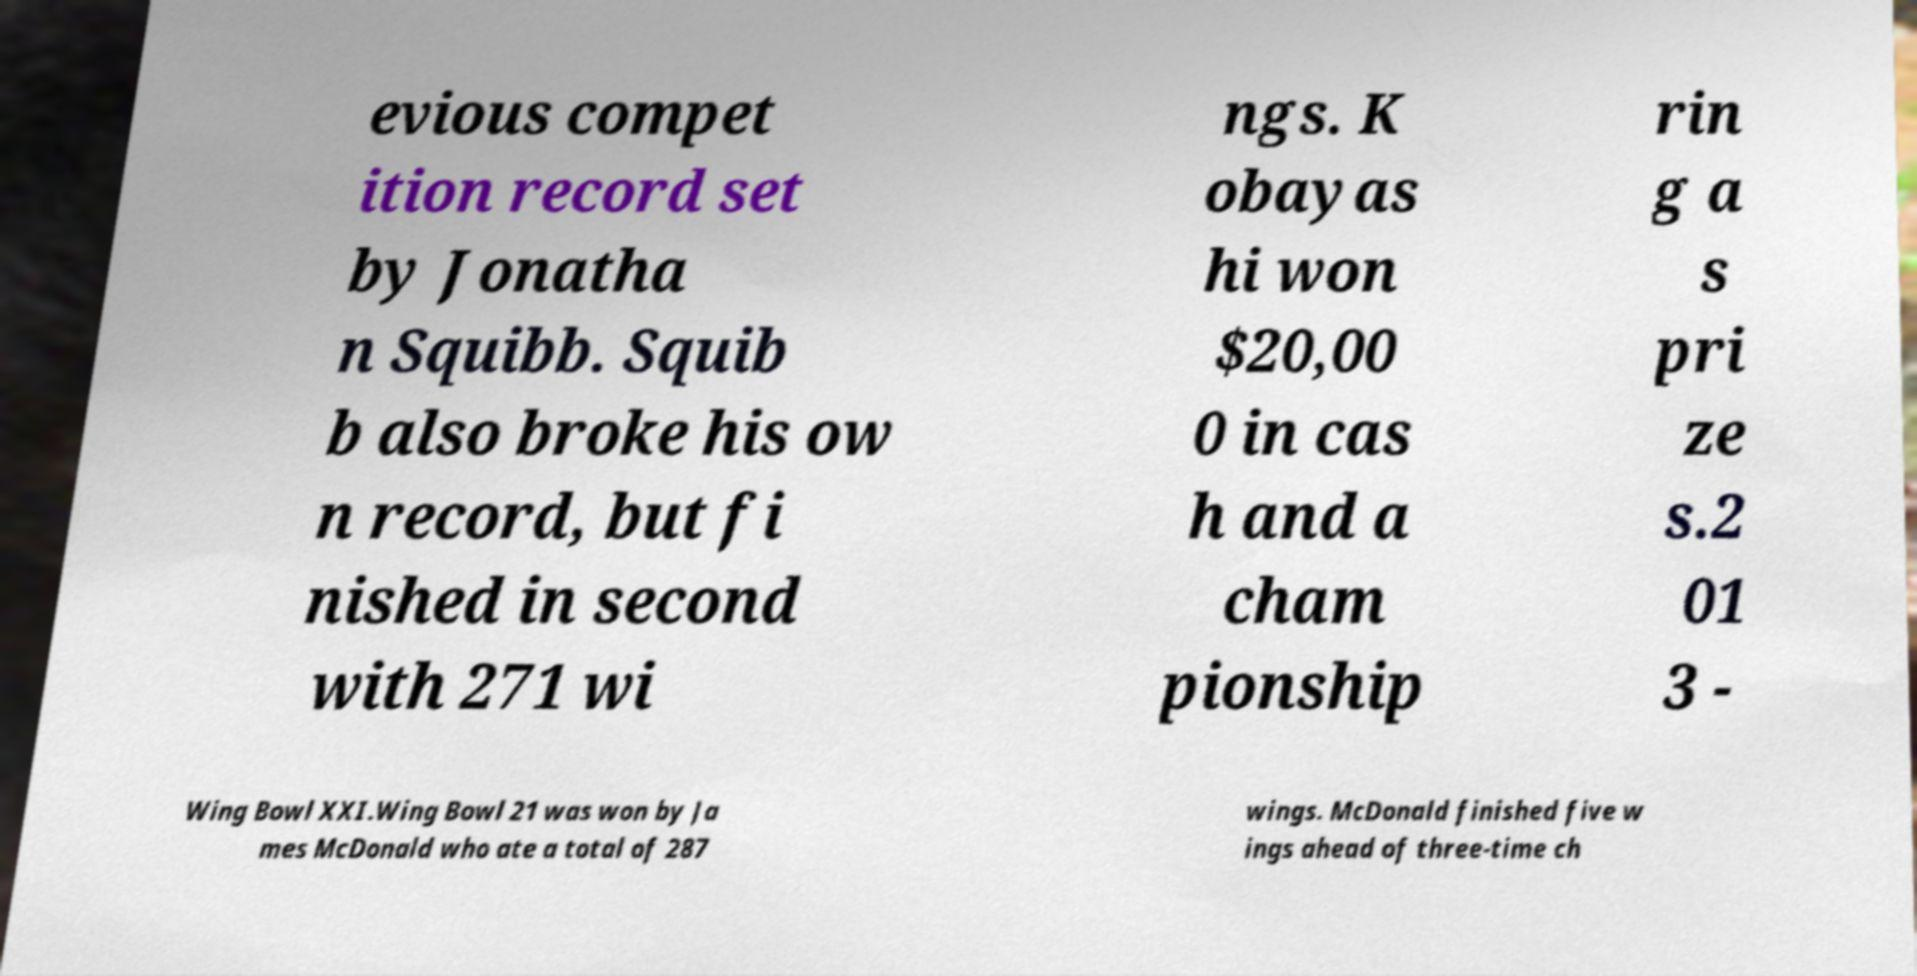For documentation purposes, I need the text within this image transcribed. Could you provide that? evious compet ition record set by Jonatha n Squibb. Squib b also broke his ow n record, but fi nished in second with 271 wi ngs. K obayas hi won $20,00 0 in cas h and a cham pionship rin g a s pri ze s.2 01 3 - Wing Bowl XXI.Wing Bowl 21 was won by Ja mes McDonald who ate a total of 287 wings. McDonald finished five w ings ahead of three-time ch 